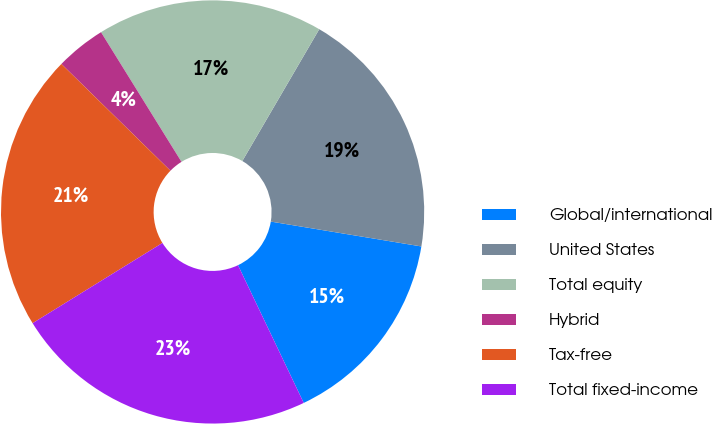Convert chart to OTSL. <chart><loc_0><loc_0><loc_500><loc_500><pie_chart><fcel>Global/international<fcel>United States<fcel>Total equity<fcel>Hybrid<fcel>Tax-free<fcel>Total fixed-income<nl><fcel>15.31%<fcel>19.2%<fcel>17.25%<fcel>3.83%<fcel>21.14%<fcel>23.28%<nl></chart> 